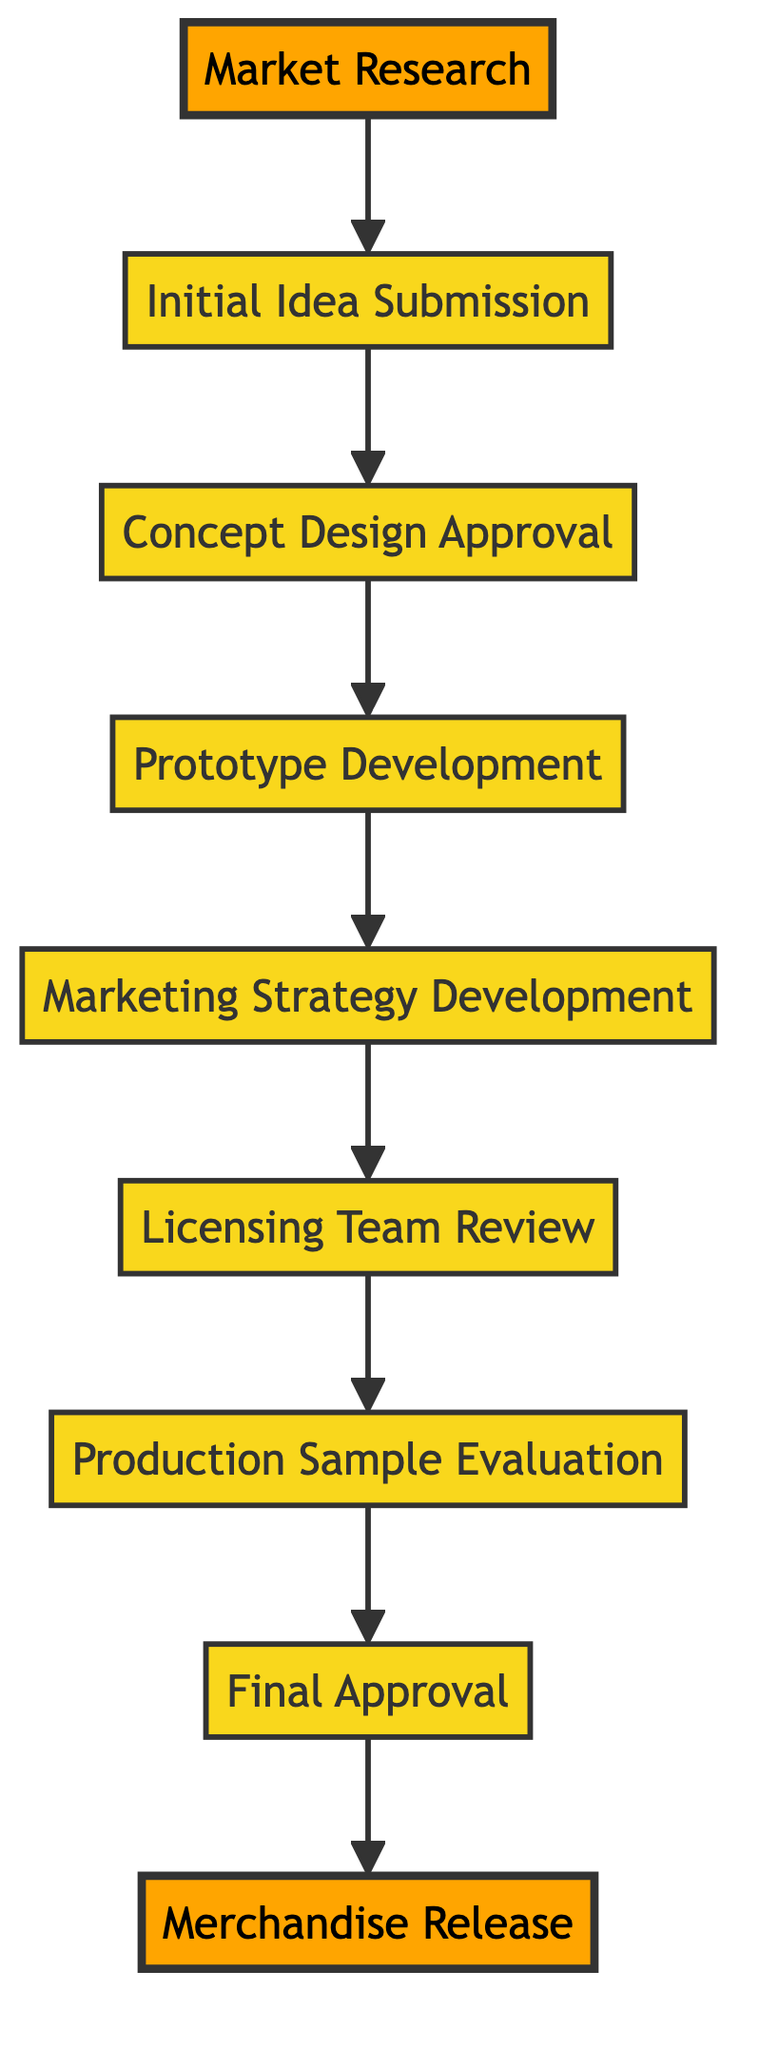What is the first step in the process? The diagram starts with "Market Research" as the first step in the merchandise concept approval process.
Answer: Market Research How many nodes are in the diagram? By counting all the individual steps represented in the diagram, there are a total of eight nodes.
Answer: Eight What step comes after "Prototype Development"? The next step indicated in the flow after "Prototype Development" is "Marketing Strategy Development."
Answer: Marketing Strategy Development Which node represents the final approval? The final approval is represented by the node labeled "Final Approval," which is positioned just before the release step.
Answer: Final Approval What is the last step in the process? The last step in the flowchart, where the process culminates, is "Merchandise Release."
Answer: Merchandise Release Which step reviews compliance with IP and brand alignment? The step dedicated to reviewing compliance with intellectual property and brand alignment is the "Licensing Team Review."
Answer: Licensing Team Review What step must occur before "Final Approval"? Before "Final Approval," the step that must occur is "Production Sample Evaluation."
Answer: Production Sample Evaluation How many steps are between "Initial Idea Submission" and "Final Approval"? There are a total of six steps that occur in succession between "Initial Idea Submission" and "Final Approval."
Answer: Six What links the "Marketing Strategy Development" and "Licensing Team Review"? The step that connects "Marketing Strategy Development" and "Licensing Team Review" is "Prototype Development."
Answer: Prototype Development 